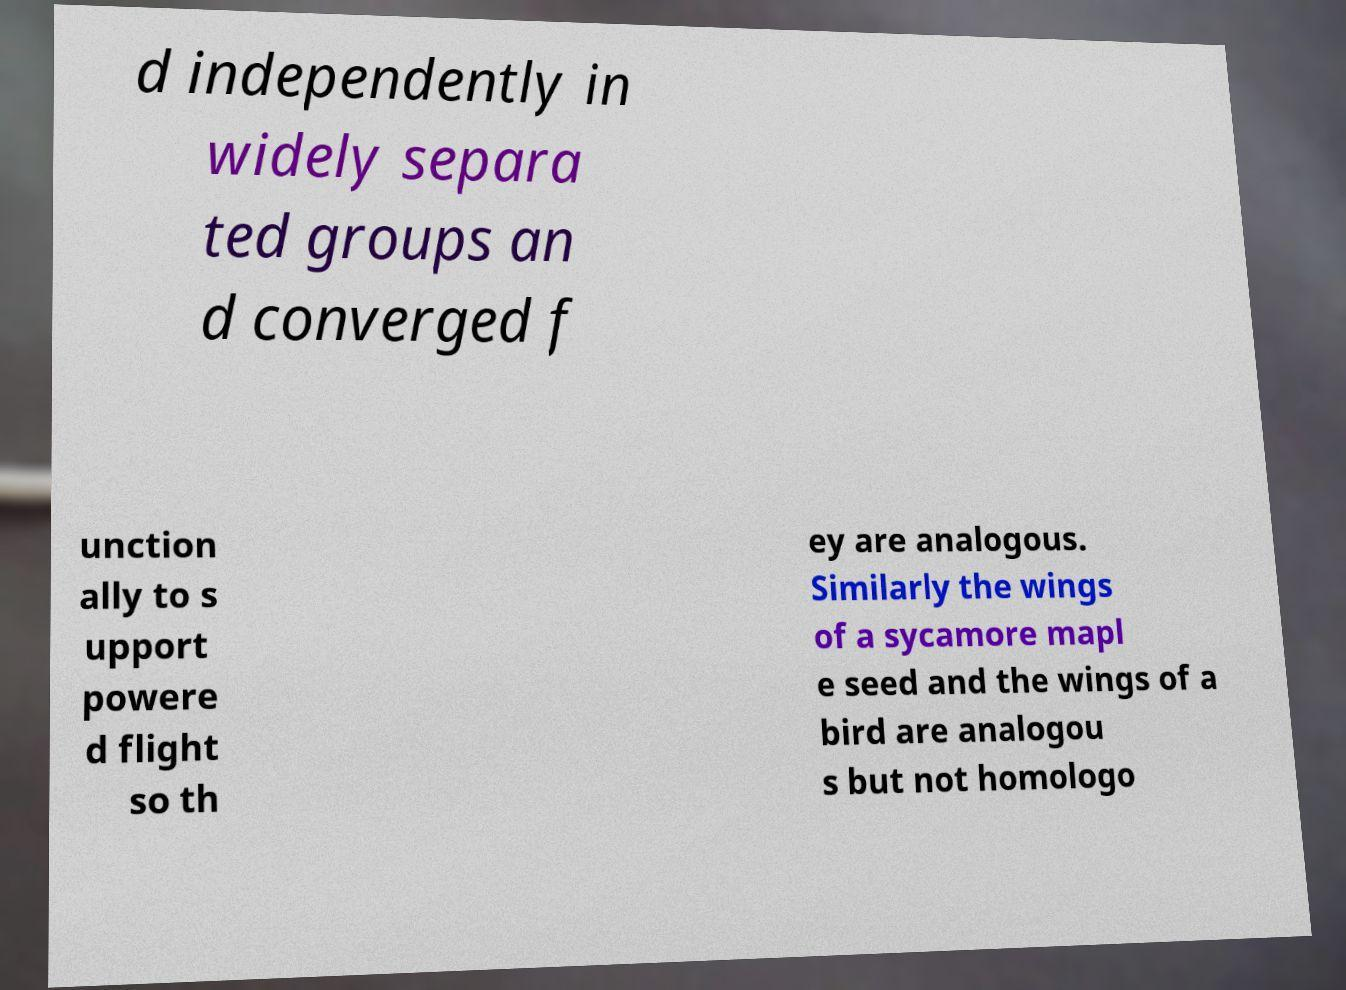Could you assist in decoding the text presented in this image and type it out clearly? d independently in widely separa ted groups an d converged f unction ally to s upport powere d flight so th ey are analogous. Similarly the wings of a sycamore mapl e seed and the wings of a bird are analogou s but not homologo 